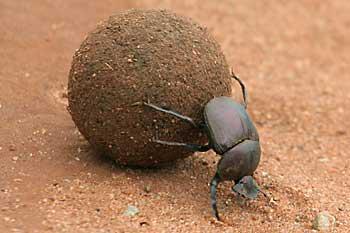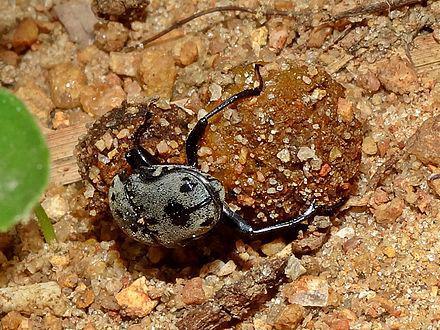The first image is the image on the left, the second image is the image on the right. Assess this claim about the two images: "An image shows one beetle in contact with one round dung ball.". Correct or not? Answer yes or no. Yes. 